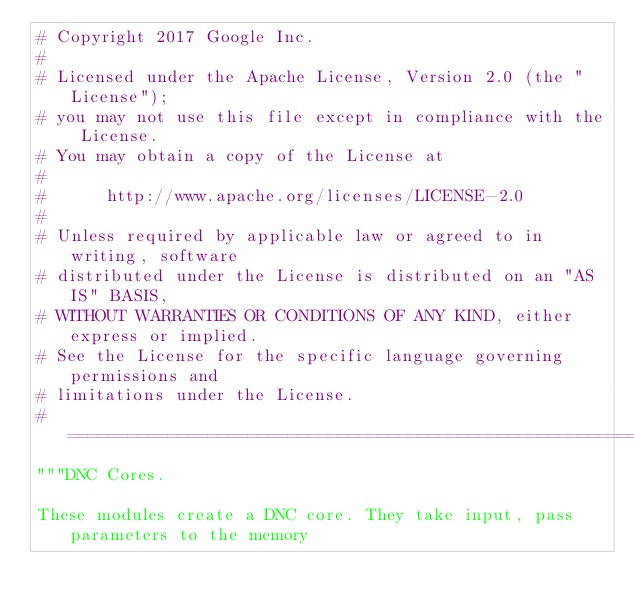<code> <loc_0><loc_0><loc_500><loc_500><_Python_># Copyright 2017 Google Inc.
#
# Licensed under the Apache License, Version 2.0 (the "License");
# you may not use this file except in compliance with the License.
# You may obtain a copy of the License at
#
#      http://www.apache.org/licenses/LICENSE-2.0
#
# Unless required by applicable law or agreed to in writing, software
# distributed under the License is distributed on an "AS IS" BASIS,
# WITHOUT WARRANTIES OR CONDITIONS OF ANY KIND, either express or implied.
# See the License for the specific language governing permissions and
# limitations under the License.
# ==============================================================================
"""DNC Cores.

These modules create a DNC core. They take input, pass parameters to the memory</code> 